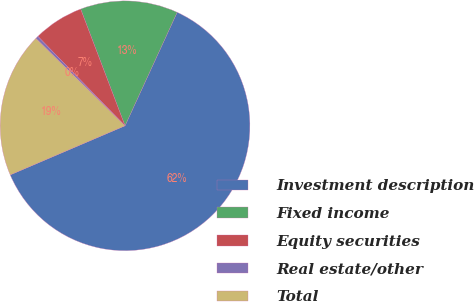<chart> <loc_0><loc_0><loc_500><loc_500><pie_chart><fcel>Investment description<fcel>Fixed income<fcel>Equity securities<fcel>Real estate/other<fcel>Total<nl><fcel>61.71%<fcel>12.64%<fcel>6.51%<fcel>0.37%<fcel>18.77%<nl></chart> 